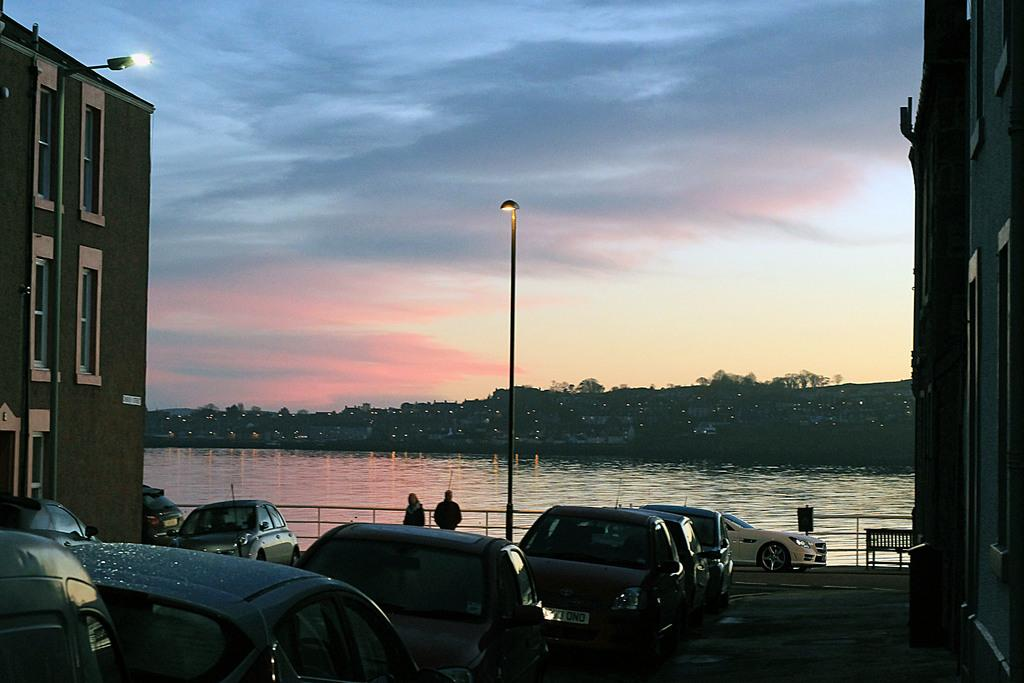What type of structures can be seen in the image? There are buildings in the image. What kind of lighting is present in the image? There is a pole light and the buildings have lights. What vehicles are parked in the image? There are cars parked in the image. What natural element is visible in the image? There is water visible in the image. How would you describe the sky in the image? The sky is blue and cloudy. Are there any people present in the image? Yes, there are people standing in the image. What type of pen is being used by the plant in the image? There is no pen or plant present in the image. How many glasses of water are visible on the table in the image? There is no table or glass of water present in the image. 